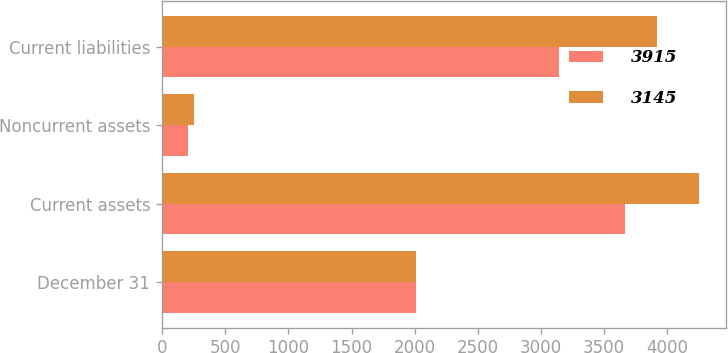Convert chart to OTSL. <chart><loc_0><loc_0><loc_500><loc_500><stacked_bar_chart><ecel><fcel>December 31<fcel>Current assets<fcel>Noncurrent assets<fcel>Current liabilities<nl><fcel>3915<fcel>2012<fcel>3662<fcel>206<fcel>3145<nl><fcel>3145<fcel>2011<fcel>4251<fcel>250<fcel>3915<nl></chart> 